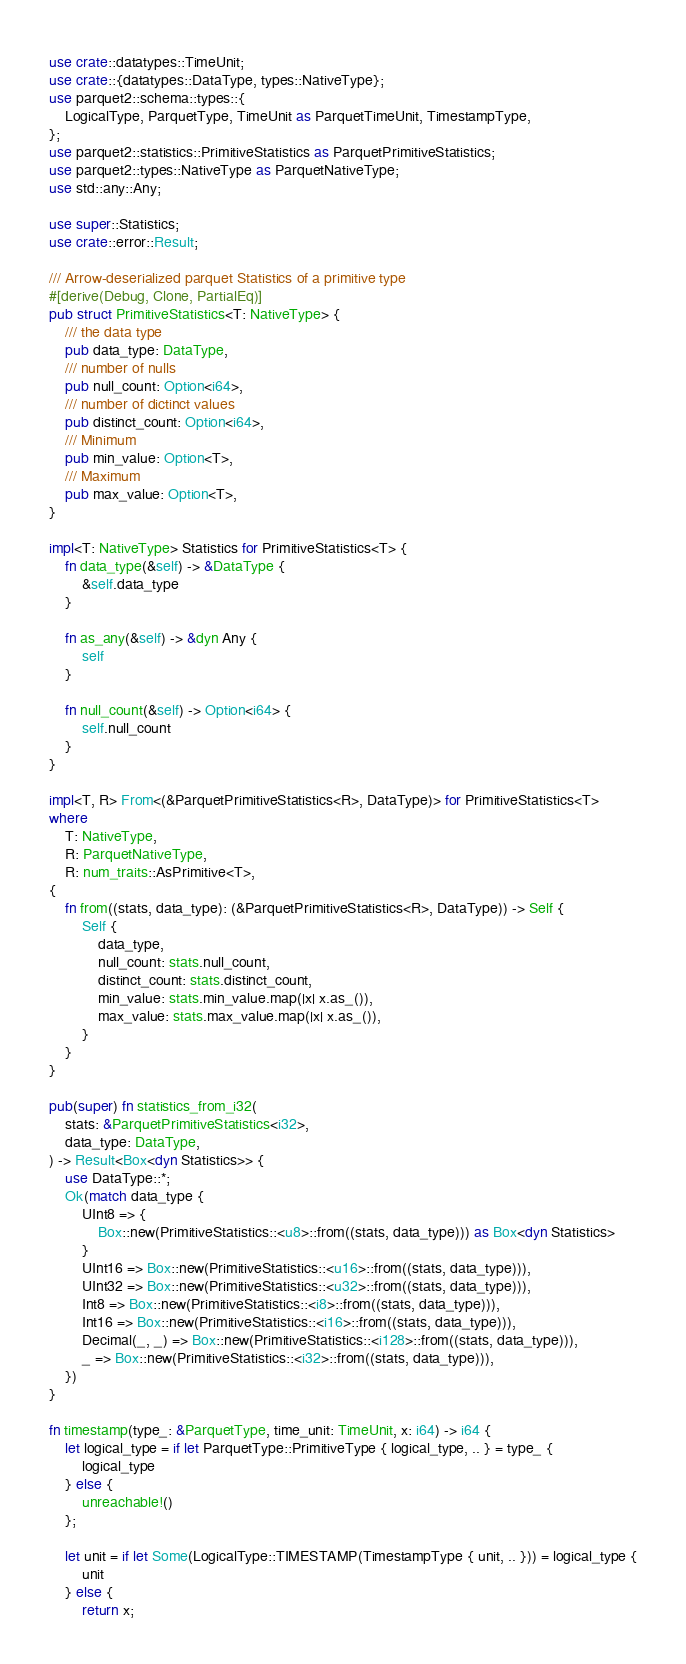Convert code to text. <code><loc_0><loc_0><loc_500><loc_500><_Rust_>use crate::datatypes::TimeUnit;
use crate::{datatypes::DataType, types::NativeType};
use parquet2::schema::types::{
    LogicalType, ParquetType, TimeUnit as ParquetTimeUnit, TimestampType,
};
use parquet2::statistics::PrimitiveStatistics as ParquetPrimitiveStatistics;
use parquet2::types::NativeType as ParquetNativeType;
use std::any::Any;

use super::Statistics;
use crate::error::Result;

/// Arrow-deserialized parquet Statistics of a primitive type
#[derive(Debug, Clone, PartialEq)]
pub struct PrimitiveStatistics<T: NativeType> {
    /// the data type
    pub data_type: DataType,
    /// number of nulls
    pub null_count: Option<i64>,
    /// number of dictinct values
    pub distinct_count: Option<i64>,
    /// Minimum
    pub min_value: Option<T>,
    /// Maximum
    pub max_value: Option<T>,
}

impl<T: NativeType> Statistics for PrimitiveStatistics<T> {
    fn data_type(&self) -> &DataType {
        &self.data_type
    }

    fn as_any(&self) -> &dyn Any {
        self
    }

    fn null_count(&self) -> Option<i64> {
        self.null_count
    }
}

impl<T, R> From<(&ParquetPrimitiveStatistics<R>, DataType)> for PrimitiveStatistics<T>
where
    T: NativeType,
    R: ParquetNativeType,
    R: num_traits::AsPrimitive<T>,
{
    fn from((stats, data_type): (&ParquetPrimitiveStatistics<R>, DataType)) -> Self {
        Self {
            data_type,
            null_count: stats.null_count,
            distinct_count: stats.distinct_count,
            min_value: stats.min_value.map(|x| x.as_()),
            max_value: stats.max_value.map(|x| x.as_()),
        }
    }
}

pub(super) fn statistics_from_i32(
    stats: &ParquetPrimitiveStatistics<i32>,
    data_type: DataType,
) -> Result<Box<dyn Statistics>> {
    use DataType::*;
    Ok(match data_type {
        UInt8 => {
            Box::new(PrimitiveStatistics::<u8>::from((stats, data_type))) as Box<dyn Statistics>
        }
        UInt16 => Box::new(PrimitiveStatistics::<u16>::from((stats, data_type))),
        UInt32 => Box::new(PrimitiveStatistics::<u32>::from((stats, data_type))),
        Int8 => Box::new(PrimitiveStatistics::<i8>::from((stats, data_type))),
        Int16 => Box::new(PrimitiveStatistics::<i16>::from((stats, data_type))),
        Decimal(_, _) => Box::new(PrimitiveStatistics::<i128>::from((stats, data_type))),
        _ => Box::new(PrimitiveStatistics::<i32>::from((stats, data_type))),
    })
}

fn timestamp(type_: &ParquetType, time_unit: TimeUnit, x: i64) -> i64 {
    let logical_type = if let ParquetType::PrimitiveType { logical_type, .. } = type_ {
        logical_type
    } else {
        unreachable!()
    };

    let unit = if let Some(LogicalType::TIMESTAMP(TimestampType { unit, .. })) = logical_type {
        unit
    } else {
        return x;</code> 